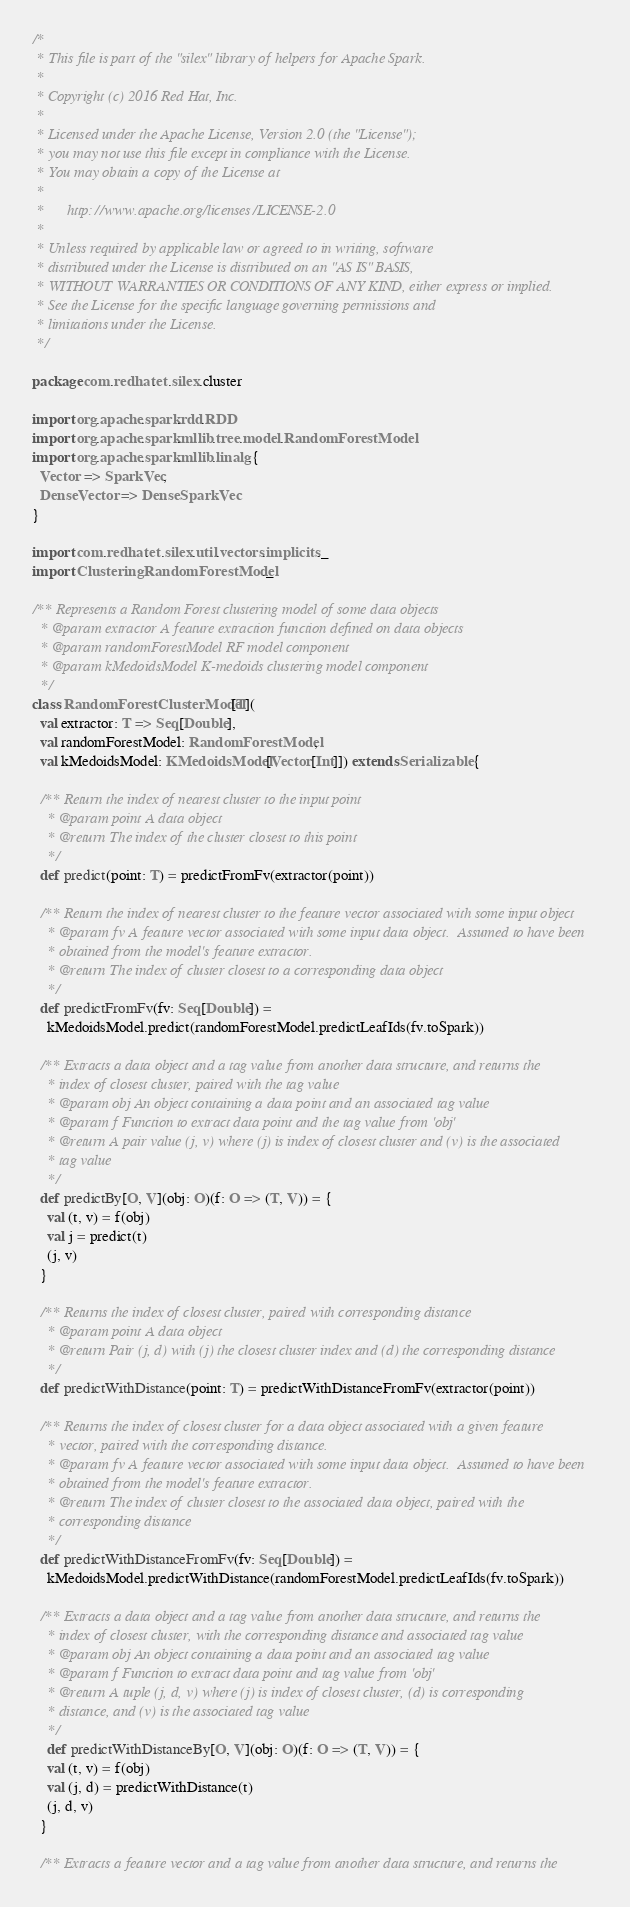<code> <loc_0><loc_0><loc_500><loc_500><_Scala_>/*
 * This file is part of the "silex" library of helpers for Apache Spark.
 *
 * Copyright (c) 2016 Red Hat, Inc.
 * 
 * Licensed under the Apache License, Version 2.0 (the "License");
 * you may not use this file except in compliance with the License.
 * You may obtain a copy of the License at
 * 
 *      http://www.apache.org/licenses/LICENSE-2.0
 * 
 * Unless required by applicable law or agreed to in writing, software
 * distributed under the License is distributed on an "AS IS" BASIS,
 * WITHOUT WARRANTIES OR CONDITIONS OF ANY KIND, either express or implied.
 * See the License for the specific language governing permissions and
 * limitations under the License.
 */

package com.redhat.et.silex.cluster

import org.apache.spark.rdd.RDD
import org.apache.spark.mllib.tree.model.RandomForestModel
import org.apache.spark.mllib.linalg.{
  Vector => SparkVec,
  DenseVector => DenseSparkVec
}

import com.redhat.et.silex.util.vectors.implicits._
import ClusteringRandomForestModel._

/** Represents a Random Forest clustering model of some data objects
  * @param extractor A feature extraction function defined on data objects
  * @param randomForestModel RF model component
  * @param kMedoidsModel K-medoids clustering model component
  */
class RandomForestClusterModel[T](
  val extractor: T => Seq[Double],
  val randomForestModel: RandomForestModel,
  val kMedoidsModel: KMedoidsModel[Vector[Int]]) extends Serializable {

  /** Return the index of nearest cluster to the input point
    * @param point A data object
    * @return The index of the cluster closest to this point
    */
  def predict(point: T) = predictFromFv(extractor(point))

  /** Return the index of nearest cluster to the feature vector associated with some input object
    * @param fv A feature vector associated with some input data object.  Assumed to have been
    * obtained from the model's feature extractor.
    * @return The index of cluster closest to a corresponding data object
    */
  def predictFromFv(fv: Seq[Double]) =
    kMedoidsModel.predict(randomForestModel.predictLeafIds(fv.toSpark))

  /** Extracts a data object and a tag value from another data structure, and returns the
    * index of closest cluster, paired with the tag value
    * @param obj An object containing a data point and an associated tag value
    * @param f Function to extract data point and the tag value from 'obj'
    * @return A pair value (j, v) where (j) is index of closest cluster and (v) is the associated
    * tag value
    */
  def predictBy[O, V](obj: O)(f: O => (T, V)) = {
    val (t, v) = f(obj)
    val j = predict(t)
    (j, v)
  }

  /** Returns the index of closest cluster, paired with corresponding distance
    * @param point A data object
    * @return Pair (j, d) with (j) the closest cluster index and (d) the corresponding distance
    */
  def predictWithDistance(point: T) = predictWithDistanceFromFv(extractor(point))

  /** Returns the index of closest cluster for a data object associated with a given feature
    * vector, paired with the corresponding distance.
    * @param fv A feature vector associated with some input data object.  Assumed to have been
    * obtained from the model's feature extractor.
    * @return The index of cluster closest to the associated data object, paired with the
    * corresponding distance
    */
  def predictWithDistanceFromFv(fv: Seq[Double]) =
    kMedoidsModel.predictWithDistance(randomForestModel.predictLeafIds(fv.toSpark))

  /** Extracts a data object and a tag value from another data structure, and returns the
    * index of closest cluster, with the corresponding distance and associated tag value
    * @param obj An object containing a data point and an associated tag value
    * @param f Function to extract data point and tag value from 'obj'
    * @return A tuple (j, d, v) where (j) is index of closest cluster, (d) is corresponding
    * distance, and (v) is the associated tag value
    */
    def predictWithDistanceBy[O, V](obj: O)(f: O => (T, V)) = {
    val (t, v) = f(obj)
    val (j, d) = predictWithDistance(t)
    (j, d, v)
  }

  /** Extracts a feature vector and a tag value from another data structure, and returns the</code> 